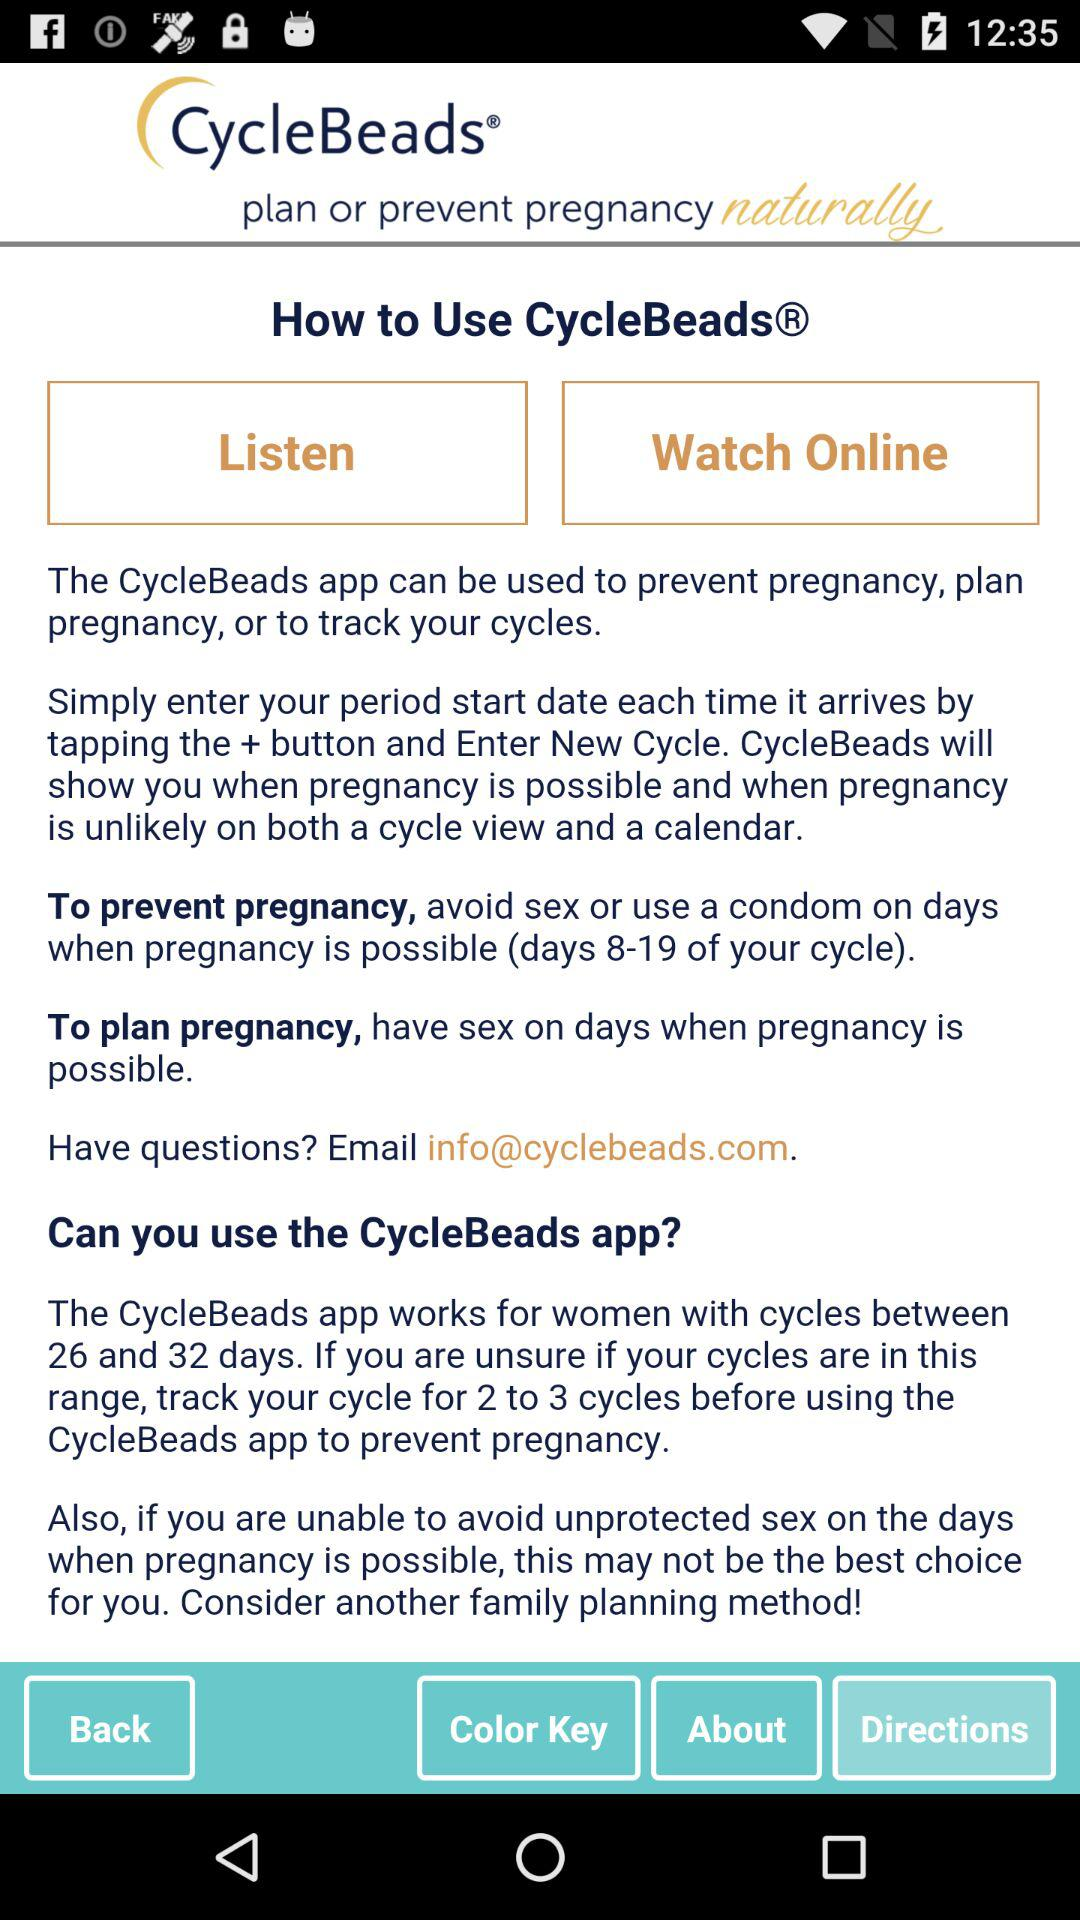What is the name of the application? The name of the application is "CycleBeads". 